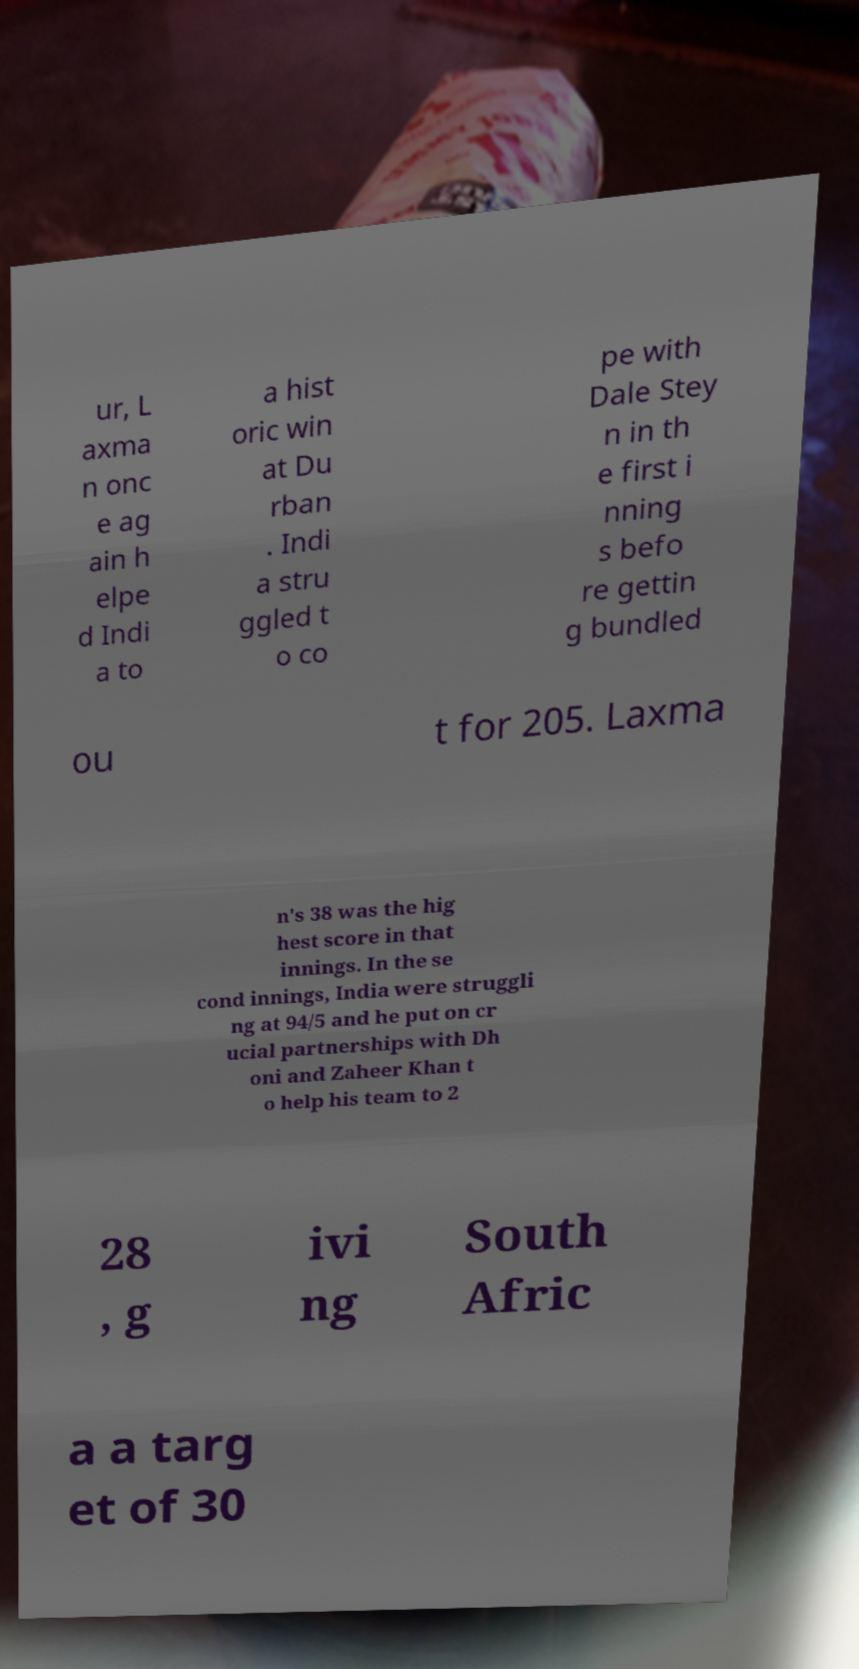Could you assist in decoding the text presented in this image and type it out clearly? ur, L axma n onc e ag ain h elpe d Indi a to a hist oric win at Du rban . Indi a stru ggled t o co pe with Dale Stey n in th e first i nning s befo re gettin g bundled ou t for 205. Laxma n's 38 was the hig hest score in that innings. In the se cond innings, India were struggli ng at 94/5 and he put on cr ucial partnerships with Dh oni and Zaheer Khan t o help his team to 2 28 , g ivi ng South Afric a a targ et of 30 